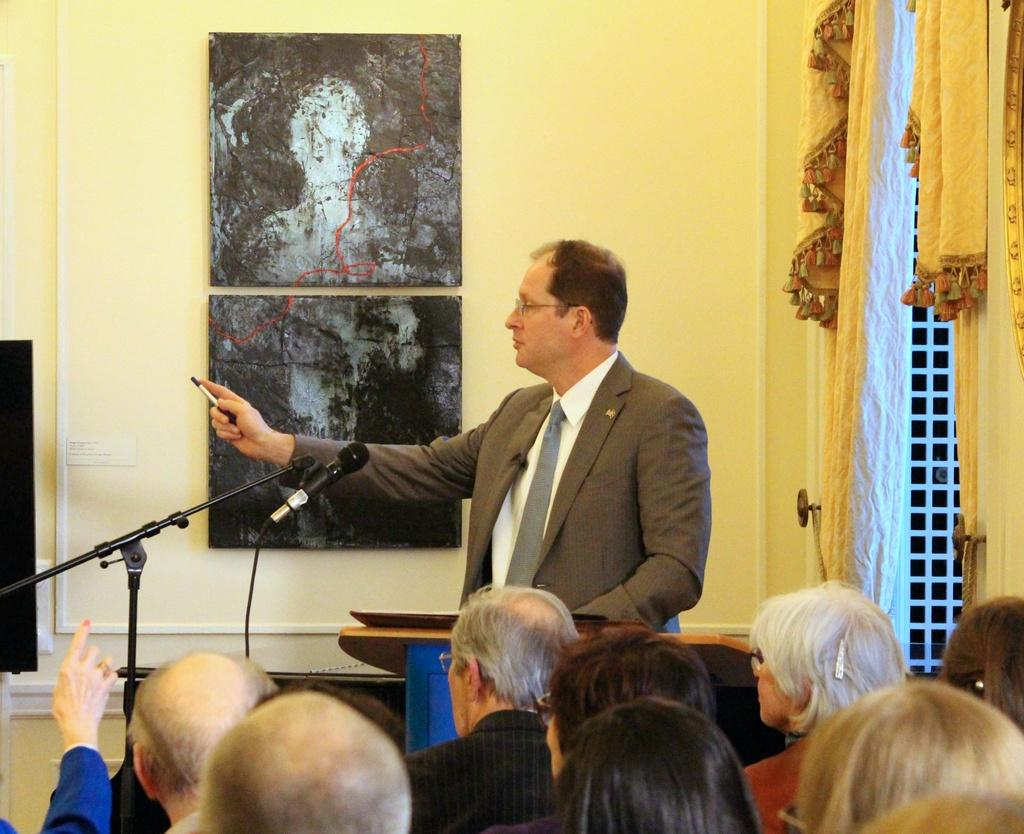How many people are in the image? There are people in the image, but the exact number is not specified. What is the person in front of the podium doing? The person is standing in front of a podium. What can be seen near the person standing at the podium? There is a microphone in the image. What type of structure is present in the image? There is a stand in the image. What type of decoration or covering is present in the image? There is a curtain in the image. What is attached to the wall in the image? There are frames attached to the wall in the image. What type of disease is being discussed by the people in the image? There is no indication of a disease being discussed in the image; it only shows people, a podium, a microphone, a stand, a curtain, and frames on the wall. 